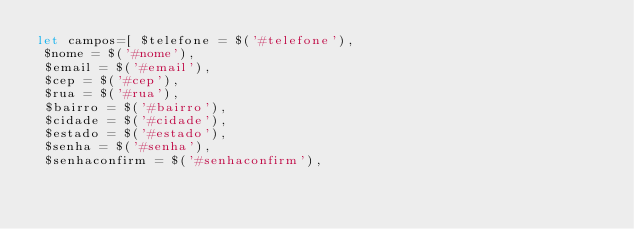<code> <loc_0><loc_0><loc_500><loc_500><_JavaScript_>let campos=[ $telefone = $('#telefone'),
 $nome = $('#nome'),
 $email = $('#email'),
 $cep = $('#cep'),
 $rua = $('#rua'),
 $bairro = $('#bairro'),
 $cidade = $('#cidade'),
 $estado = $('#estado'),
 $senha = $('#senha'),
 $senhaconfirm = $('#senhaconfirm'),</code> 